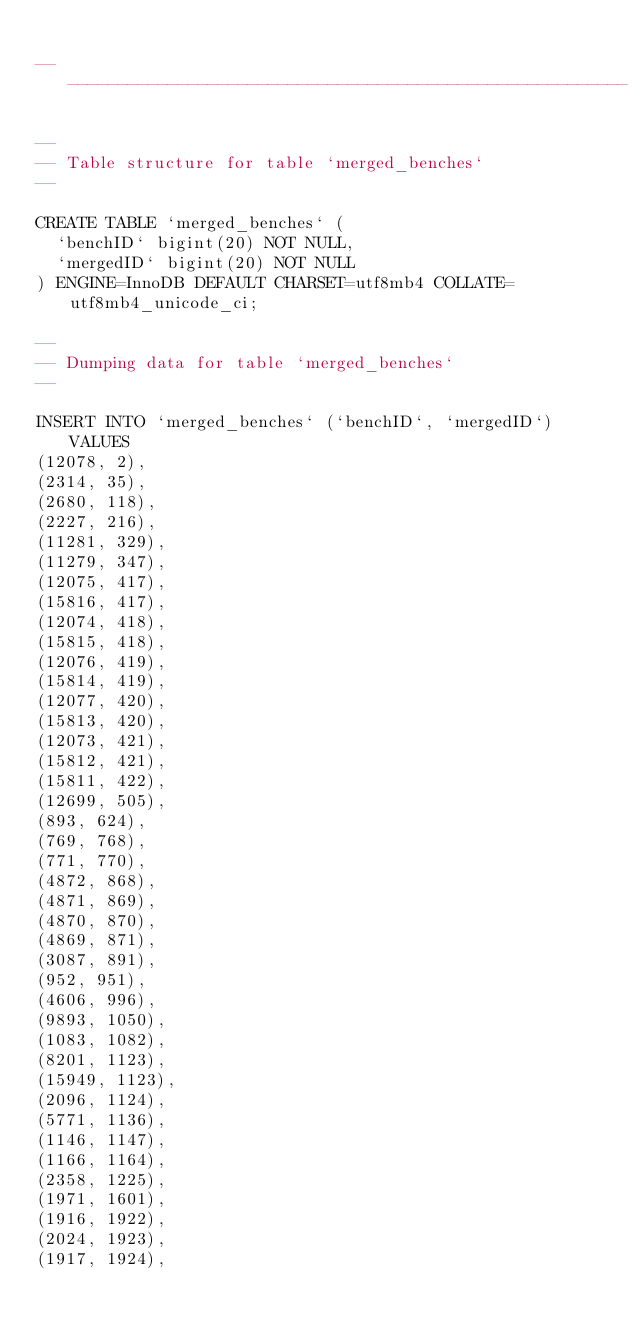Convert code to text. <code><loc_0><loc_0><loc_500><loc_500><_SQL_>
-- --------------------------------------------------------

--
-- Table structure for table `merged_benches`
--

CREATE TABLE `merged_benches` (
  `benchID` bigint(20) NOT NULL,
  `mergedID` bigint(20) NOT NULL
) ENGINE=InnoDB DEFAULT CHARSET=utf8mb4 COLLATE=utf8mb4_unicode_ci;

--
-- Dumping data for table `merged_benches`
--

INSERT INTO `merged_benches` (`benchID`, `mergedID`) VALUES
(12078, 2),
(2314, 35),
(2680, 118),
(2227, 216),
(11281, 329),
(11279, 347),
(12075, 417),
(15816, 417),
(12074, 418),
(15815, 418),
(12076, 419),
(15814, 419),
(12077, 420),
(15813, 420),
(12073, 421),
(15812, 421),
(15811, 422),
(12699, 505),
(893, 624),
(769, 768),
(771, 770),
(4872, 868),
(4871, 869),
(4870, 870),
(4869, 871),
(3087, 891),
(952, 951),
(4606, 996),
(9893, 1050),
(1083, 1082),
(8201, 1123),
(15949, 1123),
(2096, 1124),
(5771, 1136),
(1146, 1147),
(1166, 1164),
(2358, 1225),
(1971, 1601),
(1916, 1922),
(2024, 1923),
(1917, 1924),</code> 